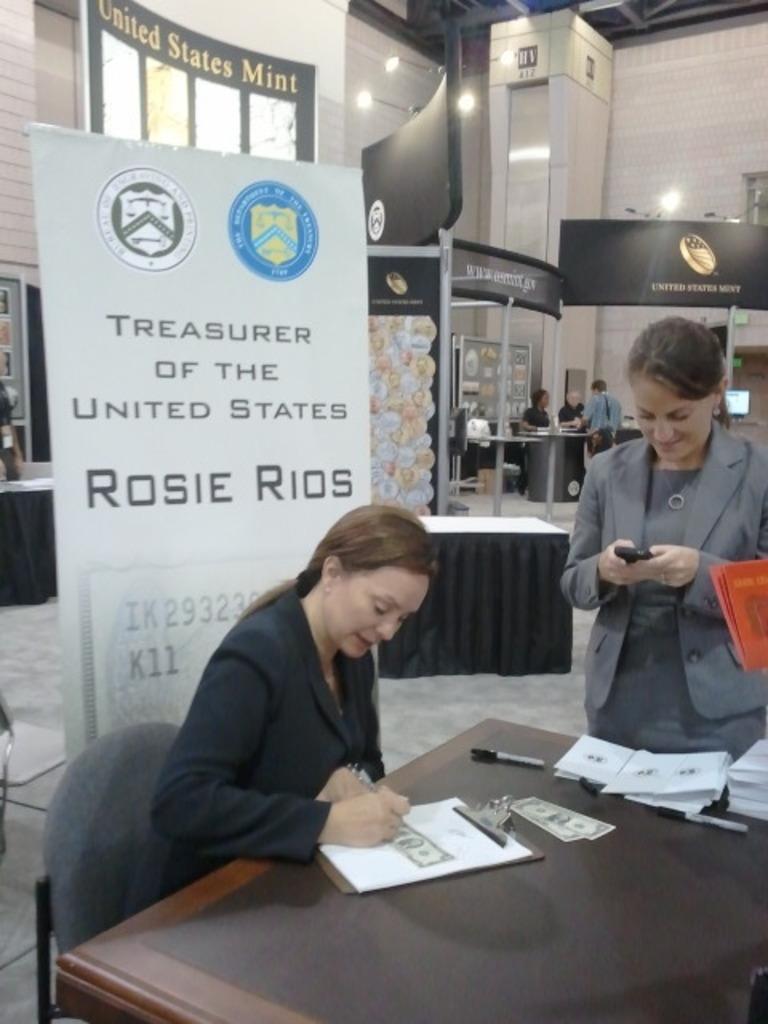Please provide a concise description of this image. This image is clicked inside a building. There are many people in this image. In the front, there is a lady sitting and wearing a black jacket. To the right, there is a woman standing and wearing a gray jacket. In the background, there is a banner, wall. At the bottom, there is a table. 